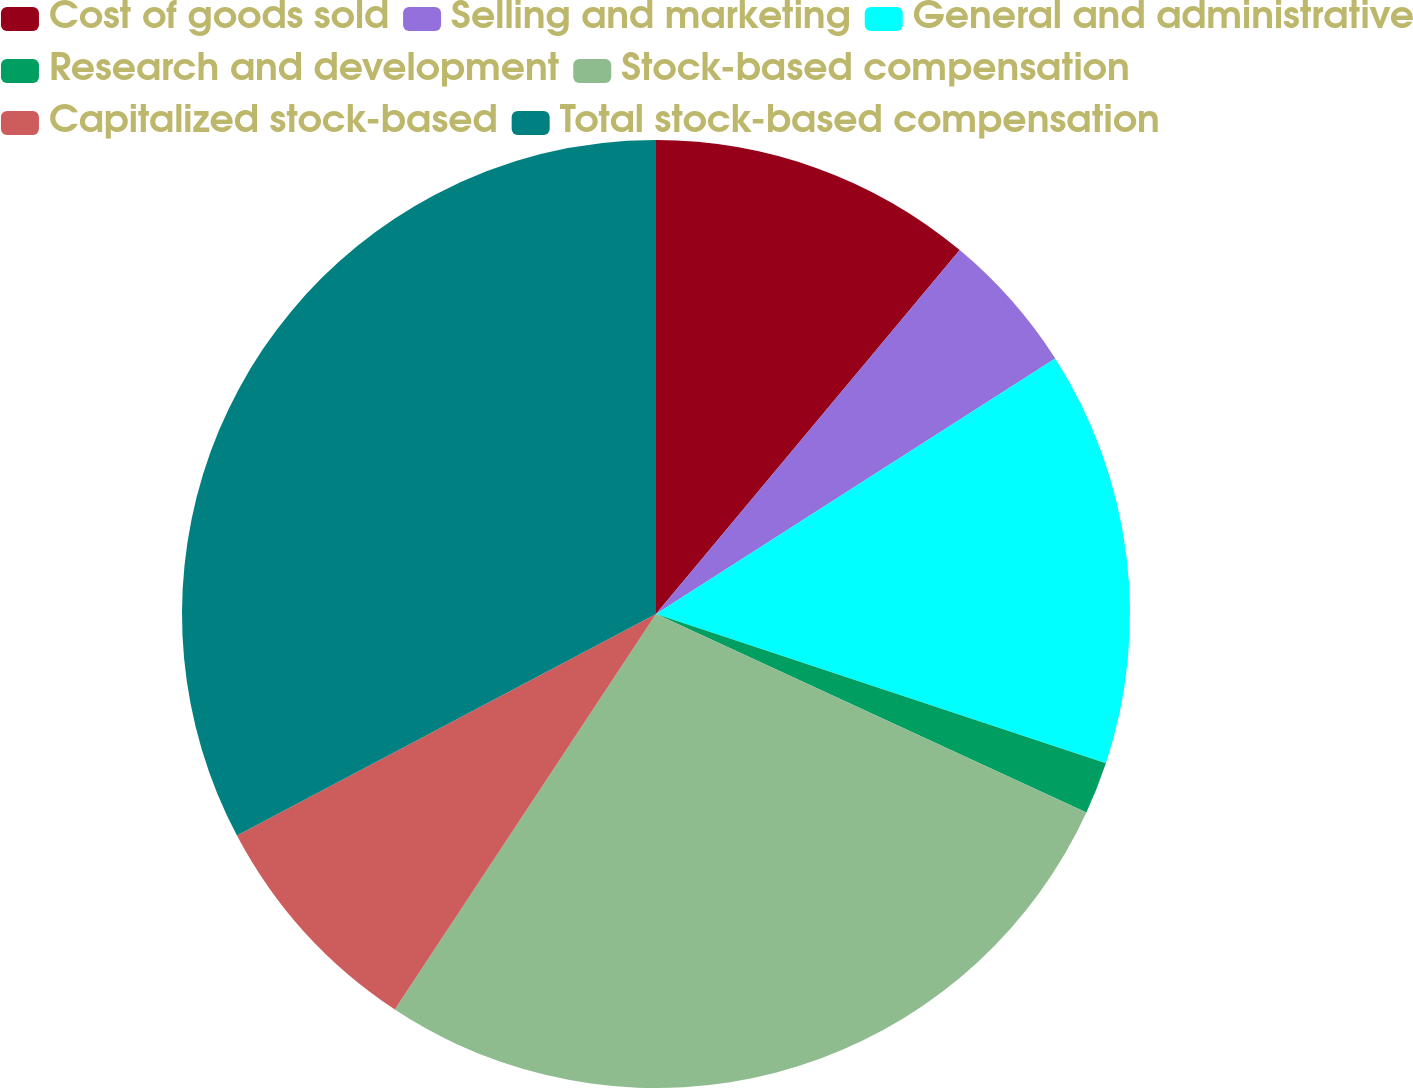Convert chart to OTSL. <chart><loc_0><loc_0><loc_500><loc_500><pie_chart><fcel>Cost of goods sold<fcel>Selling and marketing<fcel>General and administrative<fcel>Research and development<fcel>Stock-based compensation<fcel>Capitalized stock-based<fcel>Total stock-based compensation<nl><fcel>11.07%<fcel>4.87%<fcel>14.16%<fcel>1.78%<fcel>27.41%<fcel>7.97%<fcel>32.74%<nl></chart> 